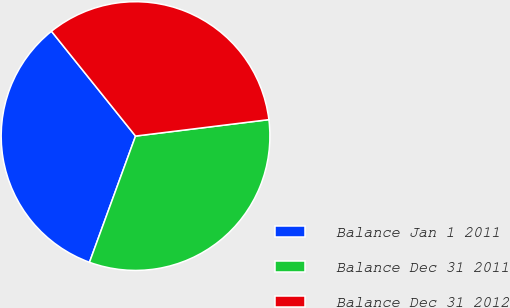Convert chart to OTSL. <chart><loc_0><loc_0><loc_500><loc_500><pie_chart><fcel>Balance Jan 1 2011<fcel>Balance Dec 31 2011<fcel>Balance Dec 31 2012<nl><fcel>33.67%<fcel>32.52%<fcel>33.81%<nl></chart> 